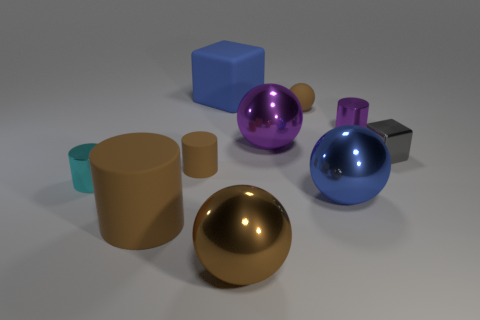Subtract all large spheres. How many spheres are left? 1 Subtract 2 spheres. How many spheres are left? 2 Subtract all cyan cylinders. How many cylinders are left? 3 Subtract all balls. How many objects are left? 6 Subtract all green spheres. Subtract all cyan blocks. How many spheres are left? 4 Subtract 1 purple cylinders. How many objects are left? 9 Subtract all large gray rubber cubes. Subtract all big brown shiny spheres. How many objects are left? 9 Add 3 small gray objects. How many small gray objects are left? 4 Add 1 small brown cylinders. How many small brown cylinders exist? 2 